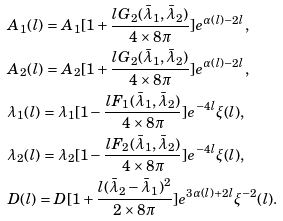<formula> <loc_0><loc_0><loc_500><loc_500>& A _ { 1 } ( l ) = A _ { 1 } [ 1 + \frac { l G _ { 2 } ( \bar { \lambda } _ { 1 } , \bar { \lambda } _ { 2 } ) } { 4 \times 8 \pi } ] e ^ { \alpha ( l ) - 2 l } , \\ & A _ { 2 } ( l ) = A _ { 2 } [ 1 + \frac { l G _ { 2 } ( \bar { \lambda } _ { 1 } , \bar { \lambda } _ { 2 } ) } { 4 \times 8 \pi } ] e ^ { \alpha ( l ) - 2 l } , \\ & \lambda _ { 1 } ( l ) = \lambda _ { 1 } [ 1 - \frac { l F _ { 1 } ( \bar { \lambda } _ { 1 } , \bar { \lambda } _ { 2 } ) } { 4 \times 8 \pi } ] e ^ { - 4 l } \xi ( l ) , \\ & \lambda _ { 2 } ( l ) = \lambda _ { 2 } [ 1 - \frac { l F _ { 2 } ( \bar { \lambda } _ { 1 } , \bar { \lambda } _ { 2 } ) } { 4 \times 8 \pi } ] e ^ { - 4 l } \xi ( l ) , \\ & D ( l ) = D [ 1 + \frac { l ( \bar { \lambda } _ { 2 } - \bar { \lambda } _ { 1 } ) ^ { 2 } } { 2 \times 8 \pi } ] e ^ { 3 \alpha ( l ) + 2 l } \xi ^ { - 2 } ( l ) .</formula> 